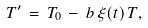<formula> <loc_0><loc_0><loc_500><loc_500>T ^ { \prime } \, = \, T _ { 0 } \, - \, b \, \xi ( t ) \, T ,</formula> 